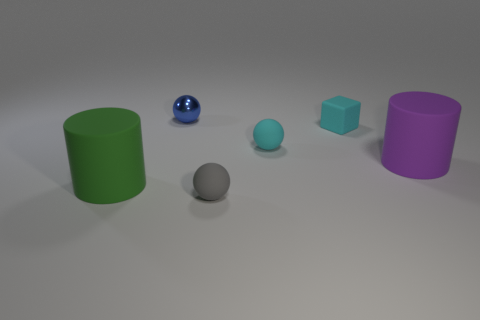Subtract all tiny cyan balls. How many balls are left? 2 Add 3 tiny cyan things. How many objects exist? 9 Subtract all cylinders. How many objects are left? 4 Add 2 tiny metallic balls. How many tiny metallic balls exist? 3 Subtract all blue balls. How many balls are left? 2 Subtract 1 purple cylinders. How many objects are left? 5 Subtract all purple cylinders. Subtract all cyan balls. How many cylinders are left? 1 Subtract all cyan rubber objects. Subtract all red things. How many objects are left? 4 Add 6 large green objects. How many large green objects are left? 7 